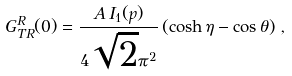Convert formula to latex. <formula><loc_0><loc_0><loc_500><loc_500>G ^ { R } _ { T R } ( 0 ) = \frac { A \, I _ { 1 } ( p ) } { 4 \sqrt { 2 } \pi ^ { 2 } } \left ( \cosh \eta - \cos \theta \right ) \, ,</formula> 